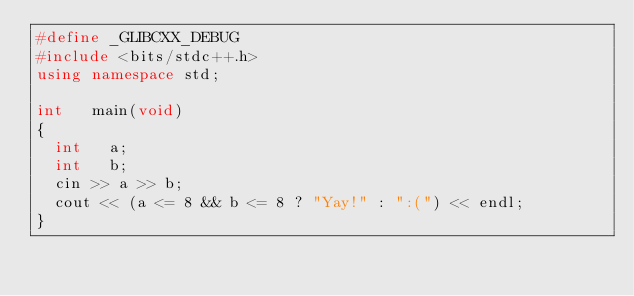<code> <loc_0><loc_0><loc_500><loc_500><_C++_>#define _GLIBCXX_DEBUG
#include <bits/stdc++.h>
using namespace std;

int		main(void)
{
	int		a;
	int		b;
	cin >> a >> b;
	cout << (a <= 8 && b <= 8 ? "Yay!" : ":(") << endl;
}</code> 